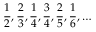Convert formula to latex. <formula><loc_0><loc_0><loc_500><loc_500>{ \frac { 1 } { 2 } } , { \frac { 2 } { 3 } } , { \frac { 1 } { 4 } } , { \frac { 3 } { 4 } } , { \frac { 2 } { 5 } } , { \frac { 1 } { 6 } } , \dots</formula> 